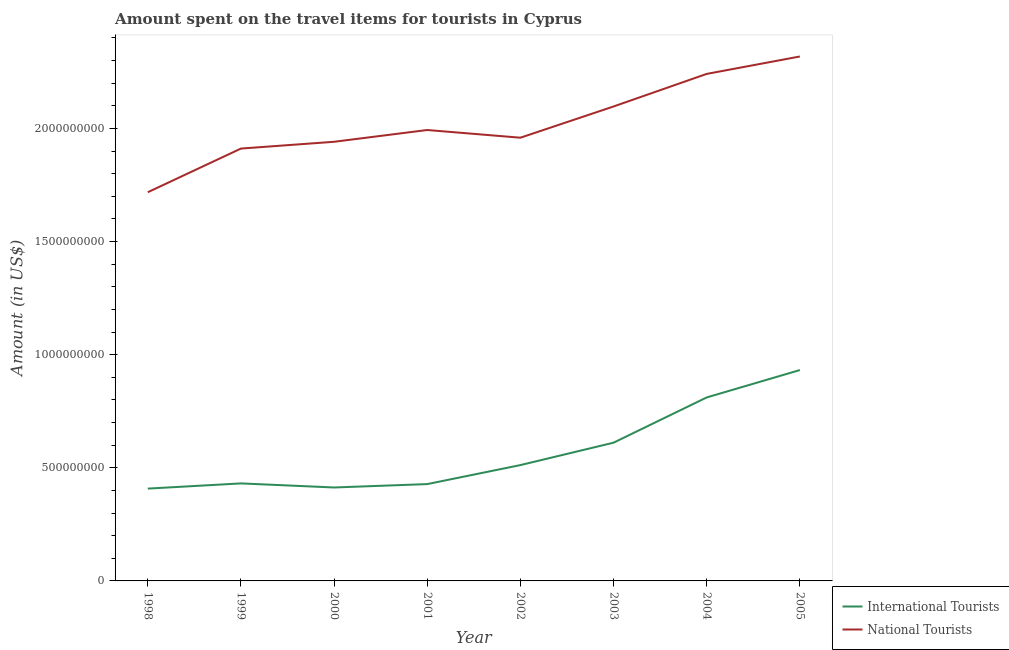How many different coloured lines are there?
Provide a succinct answer. 2. Does the line corresponding to amount spent on travel items of international tourists intersect with the line corresponding to amount spent on travel items of national tourists?
Make the answer very short. No. What is the amount spent on travel items of international tourists in 2003?
Provide a short and direct response. 6.11e+08. Across all years, what is the maximum amount spent on travel items of international tourists?
Your answer should be compact. 9.32e+08. Across all years, what is the minimum amount spent on travel items of national tourists?
Make the answer very short. 1.72e+09. In which year was the amount spent on travel items of international tourists minimum?
Make the answer very short. 1998. What is the total amount spent on travel items of international tourists in the graph?
Provide a succinct answer. 4.55e+09. What is the difference between the amount spent on travel items of national tourists in 2000 and that in 2004?
Your answer should be very brief. -3.00e+08. What is the difference between the amount spent on travel items of international tourists in 2000 and the amount spent on travel items of national tourists in 2005?
Offer a terse response. -1.90e+09. What is the average amount spent on travel items of international tourists per year?
Offer a very short reply. 5.68e+08. In the year 2003, what is the difference between the amount spent on travel items of international tourists and amount spent on travel items of national tourists?
Offer a very short reply. -1.49e+09. What is the ratio of the amount spent on travel items of international tourists in 1998 to that in 2003?
Ensure brevity in your answer.  0.67. Is the amount spent on travel items of international tourists in 2002 less than that in 2003?
Ensure brevity in your answer.  Yes. What is the difference between the highest and the second highest amount spent on travel items of international tourists?
Give a very brief answer. 1.21e+08. What is the difference between the highest and the lowest amount spent on travel items of international tourists?
Offer a terse response. 5.24e+08. In how many years, is the amount spent on travel items of international tourists greater than the average amount spent on travel items of international tourists taken over all years?
Keep it short and to the point. 3. Does the amount spent on travel items of international tourists monotonically increase over the years?
Provide a succinct answer. No. Is the amount spent on travel items of international tourists strictly less than the amount spent on travel items of national tourists over the years?
Your answer should be very brief. Yes. How many years are there in the graph?
Give a very brief answer. 8. Does the graph contain any zero values?
Provide a succinct answer. No. How many legend labels are there?
Your response must be concise. 2. What is the title of the graph?
Your answer should be compact. Amount spent on the travel items for tourists in Cyprus. What is the Amount (in US$) in International Tourists in 1998?
Your answer should be very brief. 4.08e+08. What is the Amount (in US$) of National Tourists in 1998?
Ensure brevity in your answer.  1.72e+09. What is the Amount (in US$) in International Tourists in 1999?
Your response must be concise. 4.31e+08. What is the Amount (in US$) in National Tourists in 1999?
Provide a short and direct response. 1.91e+09. What is the Amount (in US$) of International Tourists in 2000?
Ensure brevity in your answer.  4.13e+08. What is the Amount (in US$) of National Tourists in 2000?
Give a very brief answer. 1.94e+09. What is the Amount (in US$) in International Tourists in 2001?
Provide a short and direct response. 4.28e+08. What is the Amount (in US$) in National Tourists in 2001?
Give a very brief answer. 1.99e+09. What is the Amount (in US$) in International Tourists in 2002?
Offer a terse response. 5.12e+08. What is the Amount (in US$) in National Tourists in 2002?
Make the answer very short. 1.96e+09. What is the Amount (in US$) in International Tourists in 2003?
Ensure brevity in your answer.  6.11e+08. What is the Amount (in US$) of National Tourists in 2003?
Your answer should be very brief. 2.10e+09. What is the Amount (in US$) of International Tourists in 2004?
Your response must be concise. 8.11e+08. What is the Amount (in US$) of National Tourists in 2004?
Ensure brevity in your answer.  2.24e+09. What is the Amount (in US$) of International Tourists in 2005?
Provide a succinct answer. 9.32e+08. What is the Amount (in US$) in National Tourists in 2005?
Your answer should be very brief. 2.32e+09. Across all years, what is the maximum Amount (in US$) in International Tourists?
Your answer should be compact. 9.32e+08. Across all years, what is the maximum Amount (in US$) of National Tourists?
Provide a succinct answer. 2.32e+09. Across all years, what is the minimum Amount (in US$) in International Tourists?
Keep it short and to the point. 4.08e+08. Across all years, what is the minimum Amount (in US$) in National Tourists?
Your answer should be very brief. 1.72e+09. What is the total Amount (in US$) in International Tourists in the graph?
Give a very brief answer. 4.55e+09. What is the total Amount (in US$) in National Tourists in the graph?
Ensure brevity in your answer.  1.62e+1. What is the difference between the Amount (in US$) of International Tourists in 1998 and that in 1999?
Your answer should be compact. -2.30e+07. What is the difference between the Amount (in US$) of National Tourists in 1998 and that in 1999?
Your answer should be compact. -1.93e+08. What is the difference between the Amount (in US$) in International Tourists in 1998 and that in 2000?
Provide a succinct answer. -5.00e+06. What is the difference between the Amount (in US$) in National Tourists in 1998 and that in 2000?
Your answer should be very brief. -2.23e+08. What is the difference between the Amount (in US$) of International Tourists in 1998 and that in 2001?
Your answer should be compact. -2.00e+07. What is the difference between the Amount (in US$) in National Tourists in 1998 and that in 2001?
Provide a short and direct response. -2.75e+08. What is the difference between the Amount (in US$) in International Tourists in 1998 and that in 2002?
Offer a terse response. -1.04e+08. What is the difference between the Amount (in US$) of National Tourists in 1998 and that in 2002?
Give a very brief answer. -2.41e+08. What is the difference between the Amount (in US$) of International Tourists in 1998 and that in 2003?
Make the answer very short. -2.03e+08. What is the difference between the Amount (in US$) of National Tourists in 1998 and that in 2003?
Provide a succinct answer. -3.79e+08. What is the difference between the Amount (in US$) of International Tourists in 1998 and that in 2004?
Offer a very short reply. -4.03e+08. What is the difference between the Amount (in US$) of National Tourists in 1998 and that in 2004?
Make the answer very short. -5.23e+08. What is the difference between the Amount (in US$) in International Tourists in 1998 and that in 2005?
Provide a succinct answer. -5.24e+08. What is the difference between the Amount (in US$) of National Tourists in 1998 and that in 2005?
Provide a succinct answer. -6.00e+08. What is the difference between the Amount (in US$) in International Tourists in 1999 and that in 2000?
Provide a succinct answer. 1.80e+07. What is the difference between the Amount (in US$) of National Tourists in 1999 and that in 2000?
Keep it short and to the point. -3.00e+07. What is the difference between the Amount (in US$) in National Tourists in 1999 and that in 2001?
Ensure brevity in your answer.  -8.20e+07. What is the difference between the Amount (in US$) of International Tourists in 1999 and that in 2002?
Provide a short and direct response. -8.10e+07. What is the difference between the Amount (in US$) in National Tourists in 1999 and that in 2002?
Ensure brevity in your answer.  -4.80e+07. What is the difference between the Amount (in US$) in International Tourists in 1999 and that in 2003?
Your answer should be compact. -1.80e+08. What is the difference between the Amount (in US$) of National Tourists in 1999 and that in 2003?
Your answer should be compact. -1.86e+08. What is the difference between the Amount (in US$) in International Tourists in 1999 and that in 2004?
Offer a terse response. -3.80e+08. What is the difference between the Amount (in US$) of National Tourists in 1999 and that in 2004?
Give a very brief answer. -3.30e+08. What is the difference between the Amount (in US$) in International Tourists in 1999 and that in 2005?
Offer a very short reply. -5.01e+08. What is the difference between the Amount (in US$) in National Tourists in 1999 and that in 2005?
Keep it short and to the point. -4.07e+08. What is the difference between the Amount (in US$) in International Tourists in 2000 and that in 2001?
Provide a short and direct response. -1.50e+07. What is the difference between the Amount (in US$) in National Tourists in 2000 and that in 2001?
Your answer should be compact. -5.20e+07. What is the difference between the Amount (in US$) in International Tourists in 2000 and that in 2002?
Offer a terse response. -9.90e+07. What is the difference between the Amount (in US$) of National Tourists in 2000 and that in 2002?
Keep it short and to the point. -1.80e+07. What is the difference between the Amount (in US$) in International Tourists in 2000 and that in 2003?
Make the answer very short. -1.98e+08. What is the difference between the Amount (in US$) in National Tourists in 2000 and that in 2003?
Keep it short and to the point. -1.56e+08. What is the difference between the Amount (in US$) in International Tourists in 2000 and that in 2004?
Offer a very short reply. -3.98e+08. What is the difference between the Amount (in US$) in National Tourists in 2000 and that in 2004?
Make the answer very short. -3.00e+08. What is the difference between the Amount (in US$) in International Tourists in 2000 and that in 2005?
Your response must be concise. -5.19e+08. What is the difference between the Amount (in US$) in National Tourists in 2000 and that in 2005?
Provide a succinct answer. -3.77e+08. What is the difference between the Amount (in US$) in International Tourists in 2001 and that in 2002?
Your answer should be compact. -8.40e+07. What is the difference between the Amount (in US$) of National Tourists in 2001 and that in 2002?
Offer a very short reply. 3.40e+07. What is the difference between the Amount (in US$) of International Tourists in 2001 and that in 2003?
Make the answer very short. -1.83e+08. What is the difference between the Amount (in US$) in National Tourists in 2001 and that in 2003?
Give a very brief answer. -1.04e+08. What is the difference between the Amount (in US$) in International Tourists in 2001 and that in 2004?
Make the answer very short. -3.83e+08. What is the difference between the Amount (in US$) of National Tourists in 2001 and that in 2004?
Provide a short and direct response. -2.48e+08. What is the difference between the Amount (in US$) in International Tourists in 2001 and that in 2005?
Your answer should be very brief. -5.04e+08. What is the difference between the Amount (in US$) in National Tourists in 2001 and that in 2005?
Your response must be concise. -3.25e+08. What is the difference between the Amount (in US$) of International Tourists in 2002 and that in 2003?
Give a very brief answer. -9.90e+07. What is the difference between the Amount (in US$) of National Tourists in 2002 and that in 2003?
Provide a short and direct response. -1.38e+08. What is the difference between the Amount (in US$) of International Tourists in 2002 and that in 2004?
Your answer should be very brief. -2.99e+08. What is the difference between the Amount (in US$) of National Tourists in 2002 and that in 2004?
Ensure brevity in your answer.  -2.82e+08. What is the difference between the Amount (in US$) in International Tourists in 2002 and that in 2005?
Make the answer very short. -4.20e+08. What is the difference between the Amount (in US$) of National Tourists in 2002 and that in 2005?
Make the answer very short. -3.59e+08. What is the difference between the Amount (in US$) in International Tourists in 2003 and that in 2004?
Give a very brief answer. -2.00e+08. What is the difference between the Amount (in US$) in National Tourists in 2003 and that in 2004?
Keep it short and to the point. -1.44e+08. What is the difference between the Amount (in US$) of International Tourists in 2003 and that in 2005?
Ensure brevity in your answer.  -3.21e+08. What is the difference between the Amount (in US$) of National Tourists in 2003 and that in 2005?
Ensure brevity in your answer.  -2.21e+08. What is the difference between the Amount (in US$) of International Tourists in 2004 and that in 2005?
Provide a short and direct response. -1.21e+08. What is the difference between the Amount (in US$) of National Tourists in 2004 and that in 2005?
Provide a succinct answer. -7.70e+07. What is the difference between the Amount (in US$) in International Tourists in 1998 and the Amount (in US$) in National Tourists in 1999?
Make the answer very short. -1.50e+09. What is the difference between the Amount (in US$) of International Tourists in 1998 and the Amount (in US$) of National Tourists in 2000?
Offer a terse response. -1.53e+09. What is the difference between the Amount (in US$) of International Tourists in 1998 and the Amount (in US$) of National Tourists in 2001?
Give a very brief answer. -1.58e+09. What is the difference between the Amount (in US$) of International Tourists in 1998 and the Amount (in US$) of National Tourists in 2002?
Offer a terse response. -1.55e+09. What is the difference between the Amount (in US$) in International Tourists in 1998 and the Amount (in US$) in National Tourists in 2003?
Provide a succinct answer. -1.69e+09. What is the difference between the Amount (in US$) of International Tourists in 1998 and the Amount (in US$) of National Tourists in 2004?
Ensure brevity in your answer.  -1.83e+09. What is the difference between the Amount (in US$) in International Tourists in 1998 and the Amount (in US$) in National Tourists in 2005?
Provide a succinct answer. -1.91e+09. What is the difference between the Amount (in US$) of International Tourists in 1999 and the Amount (in US$) of National Tourists in 2000?
Make the answer very short. -1.51e+09. What is the difference between the Amount (in US$) of International Tourists in 1999 and the Amount (in US$) of National Tourists in 2001?
Your answer should be very brief. -1.56e+09. What is the difference between the Amount (in US$) of International Tourists in 1999 and the Amount (in US$) of National Tourists in 2002?
Your response must be concise. -1.53e+09. What is the difference between the Amount (in US$) in International Tourists in 1999 and the Amount (in US$) in National Tourists in 2003?
Your response must be concise. -1.67e+09. What is the difference between the Amount (in US$) in International Tourists in 1999 and the Amount (in US$) in National Tourists in 2004?
Make the answer very short. -1.81e+09. What is the difference between the Amount (in US$) in International Tourists in 1999 and the Amount (in US$) in National Tourists in 2005?
Your answer should be compact. -1.89e+09. What is the difference between the Amount (in US$) in International Tourists in 2000 and the Amount (in US$) in National Tourists in 2001?
Your answer should be compact. -1.58e+09. What is the difference between the Amount (in US$) in International Tourists in 2000 and the Amount (in US$) in National Tourists in 2002?
Your response must be concise. -1.55e+09. What is the difference between the Amount (in US$) of International Tourists in 2000 and the Amount (in US$) of National Tourists in 2003?
Your answer should be very brief. -1.68e+09. What is the difference between the Amount (in US$) in International Tourists in 2000 and the Amount (in US$) in National Tourists in 2004?
Your answer should be compact. -1.83e+09. What is the difference between the Amount (in US$) in International Tourists in 2000 and the Amount (in US$) in National Tourists in 2005?
Offer a very short reply. -1.90e+09. What is the difference between the Amount (in US$) in International Tourists in 2001 and the Amount (in US$) in National Tourists in 2002?
Your answer should be compact. -1.53e+09. What is the difference between the Amount (in US$) in International Tourists in 2001 and the Amount (in US$) in National Tourists in 2003?
Keep it short and to the point. -1.67e+09. What is the difference between the Amount (in US$) in International Tourists in 2001 and the Amount (in US$) in National Tourists in 2004?
Give a very brief answer. -1.81e+09. What is the difference between the Amount (in US$) in International Tourists in 2001 and the Amount (in US$) in National Tourists in 2005?
Your answer should be compact. -1.89e+09. What is the difference between the Amount (in US$) in International Tourists in 2002 and the Amount (in US$) in National Tourists in 2003?
Ensure brevity in your answer.  -1.58e+09. What is the difference between the Amount (in US$) of International Tourists in 2002 and the Amount (in US$) of National Tourists in 2004?
Offer a very short reply. -1.73e+09. What is the difference between the Amount (in US$) in International Tourists in 2002 and the Amount (in US$) in National Tourists in 2005?
Your answer should be compact. -1.81e+09. What is the difference between the Amount (in US$) in International Tourists in 2003 and the Amount (in US$) in National Tourists in 2004?
Make the answer very short. -1.63e+09. What is the difference between the Amount (in US$) of International Tourists in 2003 and the Amount (in US$) of National Tourists in 2005?
Your response must be concise. -1.71e+09. What is the difference between the Amount (in US$) of International Tourists in 2004 and the Amount (in US$) of National Tourists in 2005?
Your answer should be very brief. -1.51e+09. What is the average Amount (in US$) in International Tourists per year?
Your answer should be compact. 5.68e+08. What is the average Amount (in US$) in National Tourists per year?
Offer a terse response. 2.02e+09. In the year 1998, what is the difference between the Amount (in US$) in International Tourists and Amount (in US$) in National Tourists?
Ensure brevity in your answer.  -1.31e+09. In the year 1999, what is the difference between the Amount (in US$) in International Tourists and Amount (in US$) in National Tourists?
Keep it short and to the point. -1.48e+09. In the year 2000, what is the difference between the Amount (in US$) in International Tourists and Amount (in US$) in National Tourists?
Keep it short and to the point. -1.53e+09. In the year 2001, what is the difference between the Amount (in US$) in International Tourists and Amount (in US$) in National Tourists?
Give a very brief answer. -1.56e+09. In the year 2002, what is the difference between the Amount (in US$) of International Tourists and Amount (in US$) of National Tourists?
Make the answer very short. -1.45e+09. In the year 2003, what is the difference between the Amount (in US$) in International Tourists and Amount (in US$) in National Tourists?
Offer a terse response. -1.49e+09. In the year 2004, what is the difference between the Amount (in US$) in International Tourists and Amount (in US$) in National Tourists?
Ensure brevity in your answer.  -1.43e+09. In the year 2005, what is the difference between the Amount (in US$) in International Tourists and Amount (in US$) in National Tourists?
Your answer should be very brief. -1.39e+09. What is the ratio of the Amount (in US$) in International Tourists in 1998 to that in 1999?
Your response must be concise. 0.95. What is the ratio of the Amount (in US$) in National Tourists in 1998 to that in 1999?
Your answer should be compact. 0.9. What is the ratio of the Amount (in US$) of International Tourists in 1998 to that in 2000?
Keep it short and to the point. 0.99. What is the ratio of the Amount (in US$) of National Tourists in 1998 to that in 2000?
Give a very brief answer. 0.89. What is the ratio of the Amount (in US$) in International Tourists in 1998 to that in 2001?
Give a very brief answer. 0.95. What is the ratio of the Amount (in US$) of National Tourists in 1998 to that in 2001?
Your answer should be very brief. 0.86. What is the ratio of the Amount (in US$) in International Tourists in 1998 to that in 2002?
Ensure brevity in your answer.  0.8. What is the ratio of the Amount (in US$) of National Tourists in 1998 to that in 2002?
Keep it short and to the point. 0.88. What is the ratio of the Amount (in US$) of International Tourists in 1998 to that in 2003?
Your response must be concise. 0.67. What is the ratio of the Amount (in US$) in National Tourists in 1998 to that in 2003?
Offer a terse response. 0.82. What is the ratio of the Amount (in US$) of International Tourists in 1998 to that in 2004?
Keep it short and to the point. 0.5. What is the ratio of the Amount (in US$) of National Tourists in 1998 to that in 2004?
Give a very brief answer. 0.77. What is the ratio of the Amount (in US$) in International Tourists in 1998 to that in 2005?
Ensure brevity in your answer.  0.44. What is the ratio of the Amount (in US$) in National Tourists in 1998 to that in 2005?
Your response must be concise. 0.74. What is the ratio of the Amount (in US$) of International Tourists in 1999 to that in 2000?
Your answer should be compact. 1.04. What is the ratio of the Amount (in US$) in National Tourists in 1999 to that in 2000?
Offer a very short reply. 0.98. What is the ratio of the Amount (in US$) of National Tourists in 1999 to that in 2001?
Provide a short and direct response. 0.96. What is the ratio of the Amount (in US$) of International Tourists in 1999 to that in 2002?
Give a very brief answer. 0.84. What is the ratio of the Amount (in US$) of National Tourists in 1999 to that in 2002?
Provide a succinct answer. 0.98. What is the ratio of the Amount (in US$) in International Tourists in 1999 to that in 2003?
Offer a very short reply. 0.71. What is the ratio of the Amount (in US$) of National Tourists in 1999 to that in 2003?
Keep it short and to the point. 0.91. What is the ratio of the Amount (in US$) of International Tourists in 1999 to that in 2004?
Ensure brevity in your answer.  0.53. What is the ratio of the Amount (in US$) of National Tourists in 1999 to that in 2004?
Your answer should be compact. 0.85. What is the ratio of the Amount (in US$) in International Tourists in 1999 to that in 2005?
Provide a succinct answer. 0.46. What is the ratio of the Amount (in US$) of National Tourists in 1999 to that in 2005?
Ensure brevity in your answer.  0.82. What is the ratio of the Amount (in US$) in International Tourists in 2000 to that in 2001?
Ensure brevity in your answer.  0.96. What is the ratio of the Amount (in US$) of National Tourists in 2000 to that in 2001?
Keep it short and to the point. 0.97. What is the ratio of the Amount (in US$) in International Tourists in 2000 to that in 2002?
Offer a very short reply. 0.81. What is the ratio of the Amount (in US$) of International Tourists in 2000 to that in 2003?
Provide a succinct answer. 0.68. What is the ratio of the Amount (in US$) of National Tourists in 2000 to that in 2003?
Keep it short and to the point. 0.93. What is the ratio of the Amount (in US$) in International Tourists in 2000 to that in 2004?
Provide a short and direct response. 0.51. What is the ratio of the Amount (in US$) of National Tourists in 2000 to that in 2004?
Give a very brief answer. 0.87. What is the ratio of the Amount (in US$) in International Tourists in 2000 to that in 2005?
Your answer should be very brief. 0.44. What is the ratio of the Amount (in US$) of National Tourists in 2000 to that in 2005?
Your answer should be very brief. 0.84. What is the ratio of the Amount (in US$) of International Tourists in 2001 to that in 2002?
Ensure brevity in your answer.  0.84. What is the ratio of the Amount (in US$) of National Tourists in 2001 to that in 2002?
Your answer should be very brief. 1.02. What is the ratio of the Amount (in US$) of International Tourists in 2001 to that in 2003?
Provide a short and direct response. 0.7. What is the ratio of the Amount (in US$) of National Tourists in 2001 to that in 2003?
Ensure brevity in your answer.  0.95. What is the ratio of the Amount (in US$) in International Tourists in 2001 to that in 2004?
Your answer should be very brief. 0.53. What is the ratio of the Amount (in US$) in National Tourists in 2001 to that in 2004?
Provide a succinct answer. 0.89. What is the ratio of the Amount (in US$) of International Tourists in 2001 to that in 2005?
Provide a succinct answer. 0.46. What is the ratio of the Amount (in US$) in National Tourists in 2001 to that in 2005?
Keep it short and to the point. 0.86. What is the ratio of the Amount (in US$) in International Tourists in 2002 to that in 2003?
Provide a succinct answer. 0.84. What is the ratio of the Amount (in US$) in National Tourists in 2002 to that in 2003?
Your response must be concise. 0.93. What is the ratio of the Amount (in US$) in International Tourists in 2002 to that in 2004?
Offer a terse response. 0.63. What is the ratio of the Amount (in US$) in National Tourists in 2002 to that in 2004?
Give a very brief answer. 0.87. What is the ratio of the Amount (in US$) in International Tourists in 2002 to that in 2005?
Give a very brief answer. 0.55. What is the ratio of the Amount (in US$) in National Tourists in 2002 to that in 2005?
Offer a very short reply. 0.85. What is the ratio of the Amount (in US$) of International Tourists in 2003 to that in 2004?
Your answer should be compact. 0.75. What is the ratio of the Amount (in US$) of National Tourists in 2003 to that in 2004?
Provide a succinct answer. 0.94. What is the ratio of the Amount (in US$) of International Tourists in 2003 to that in 2005?
Keep it short and to the point. 0.66. What is the ratio of the Amount (in US$) of National Tourists in 2003 to that in 2005?
Your answer should be compact. 0.9. What is the ratio of the Amount (in US$) in International Tourists in 2004 to that in 2005?
Offer a terse response. 0.87. What is the ratio of the Amount (in US$) of National Tourists in 2004 to that in 2005?
Your answer should be compact. 0.97. What is the difference between the highest and the second highest Amount (in US$) of International Tourists?
Keep it short and to the point. 1.21e+08. What is the difference between the highest and the second highest Amount (in US$) of National Tourists?
Provide a succinct answer. 7.70e+07. What is the difference between the highest and the lowest Amount (in US$) of International Tourists?
Provide a succinct answer. 5.24e+08. What is the difference between the highest and the lowest Amount (in US$) of National Tourists?
Keep it short and to the point. 6.00e+08. 